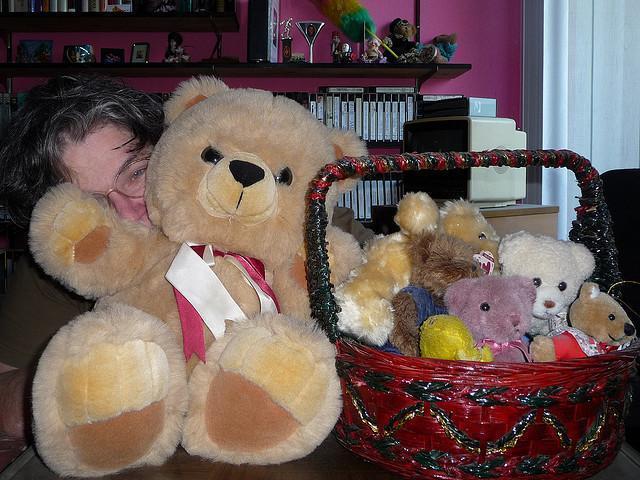How many teddy bears are in the photo?
Give a very brief answer. 7. How many apples do you see?
Give a very brief answer. 0. 